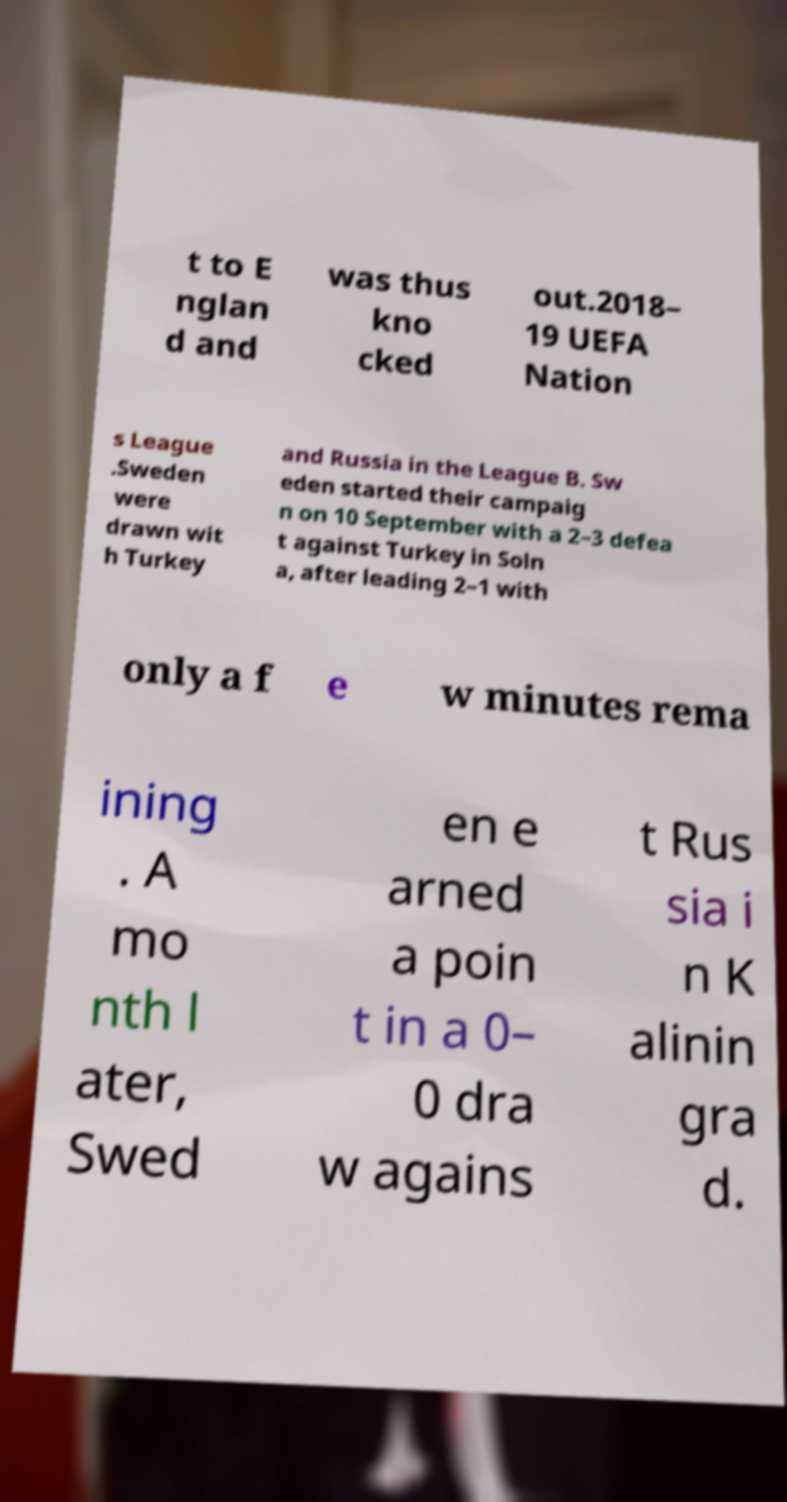Could you extract and type out the text from this image? t to E nglan d and was thus kno cked out.2018– 19 UEFA Nation s League .Sweden were drawn wit h Turkey and Russia in the League B. Sw eden started their campaig n on 10 September with a 2–3 defea t against Turkey in Soln a, after leading 2–1 with only a f e w minutes rema ining . A mo nth l ater, Swed en e arned a poin t in a 0– 0 dra w agains t Rus sia i n K alinin gra d. 